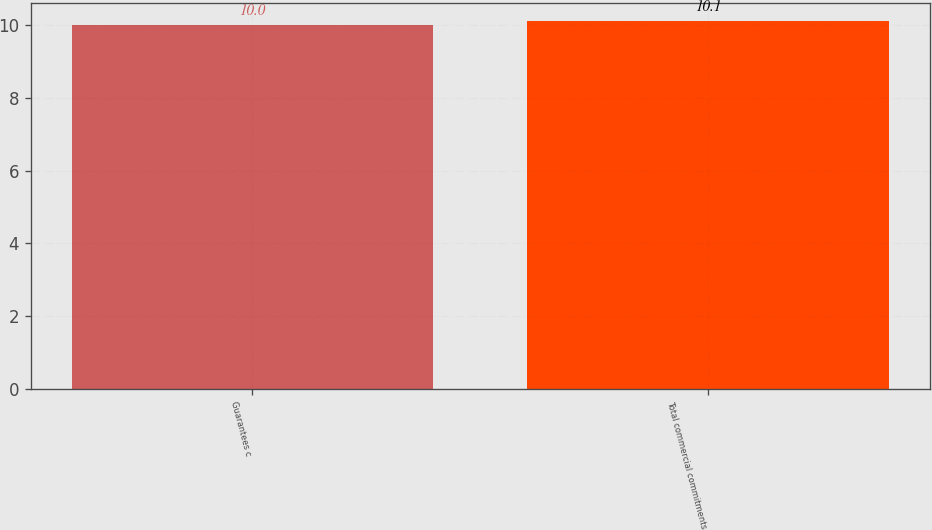Convert chart. <chart><loc_0><loc_0><loc_500><loc_500><bar_chart><fcel>Guarantees c<fcel>Total commercial commitments<nl><fcel>10<fcel>10.1<nl></chart> 